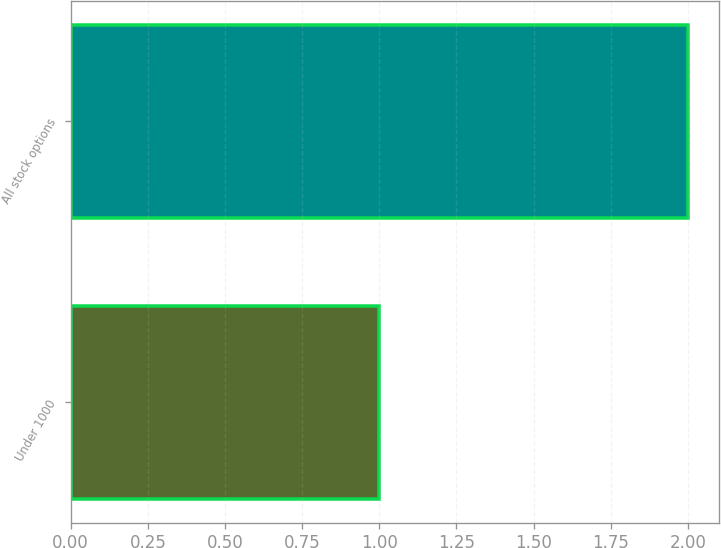<chart> <loc_0><loc_0><loc_500><loc_500><bar_chart><fcel>Under 1000<fcel>All stock options<nl><fcel>1<fcel>2<nl></chart> 